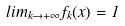<formula> <loc_0><loc_0><loc_500><loc_500>l i m _ { k \rightarrow + \infty } f _ { k } ( x ) = 1</formula> 